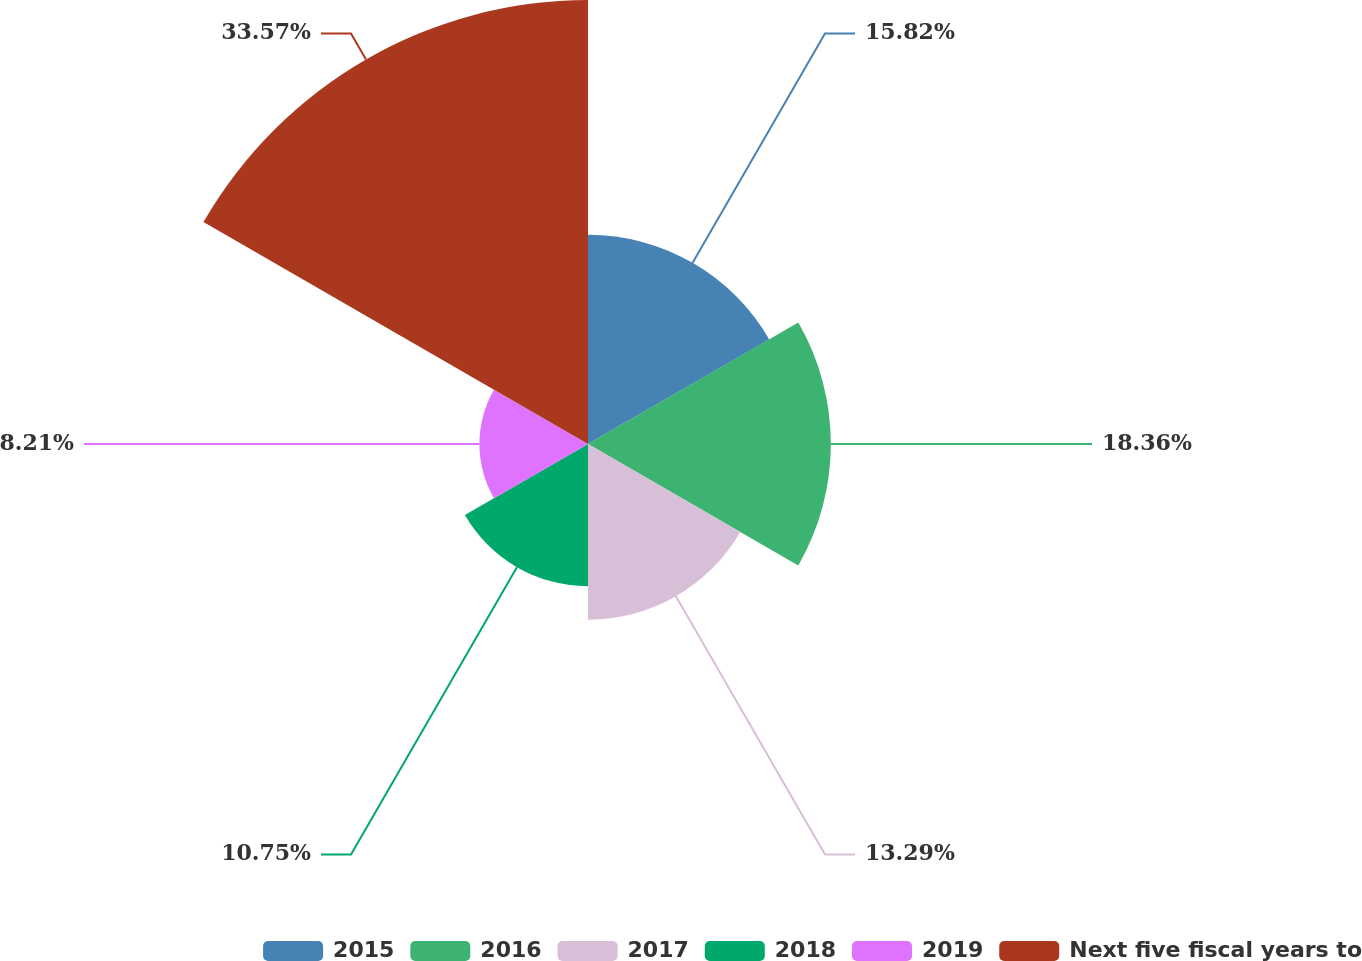Convert chart to OTSL. <chart><loc_0><loc_0><loc_500><loc_500><pie_chart><fcel>2015<fcel>2016<fcel>2017<fcel>2018<fcel>2019<fcel>Next five fiscal years to<nl><fcel>15.82%<fcel>18.36%<fcel>13.29%<fcel>10.75%<fcel>8.21%<fcel>33.57%<nl></chart> 